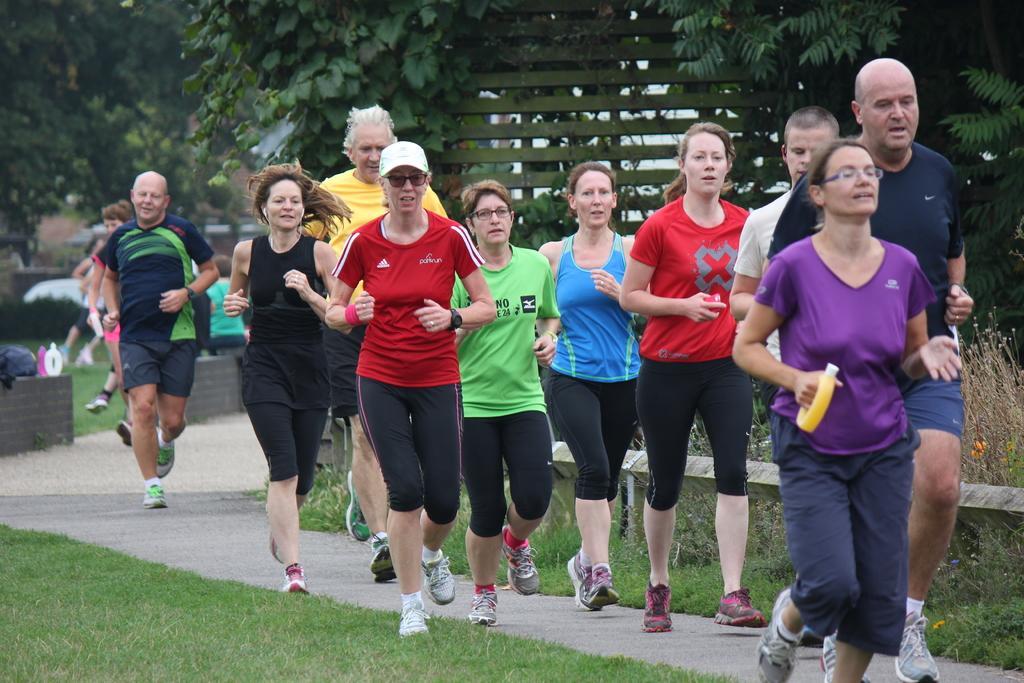How would you summarize this image in a sentence or two? There are people running and we can see grass and plants. Background we can see trees and objects on wall. 